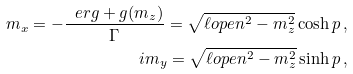Convert formula to latex. <formula><loc_0><loc_0><loc_500><loc_500>m _ { x } = - \frac { \ e r g + g ( m _ { z } ) } { \Gamma } = \sqrt { \ell o p e n ^ { 2 } - m _ { z } ^ { 2 } } \cosh p \, , \\ i m _ { y } = \sqrt { \ell o p e n ^ { 2 } - m _ { z } ^ { 2 } } \sinh p \, ,</formula> 